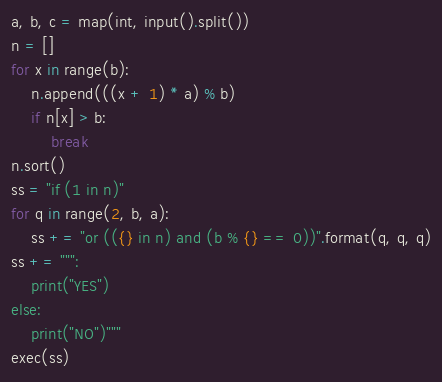Convert code to text. <code><loc_0><loc_0><loc_500><loc_500><_Python_>a, b, c = map(int, input().split())
n = []
for x in range(b):
    n.append(((x + 1) * a) % b)
    if n[x] > b:
        break
n.sort()
ss = "if (1 in n)"
for q in range(2, b, a):
    ss += "or (({} in n) and (b % {} == 0))".format(q, q, q)
ss += """:
    print("YES")
else:
    print("NO")"""
exec(ss)</code> 